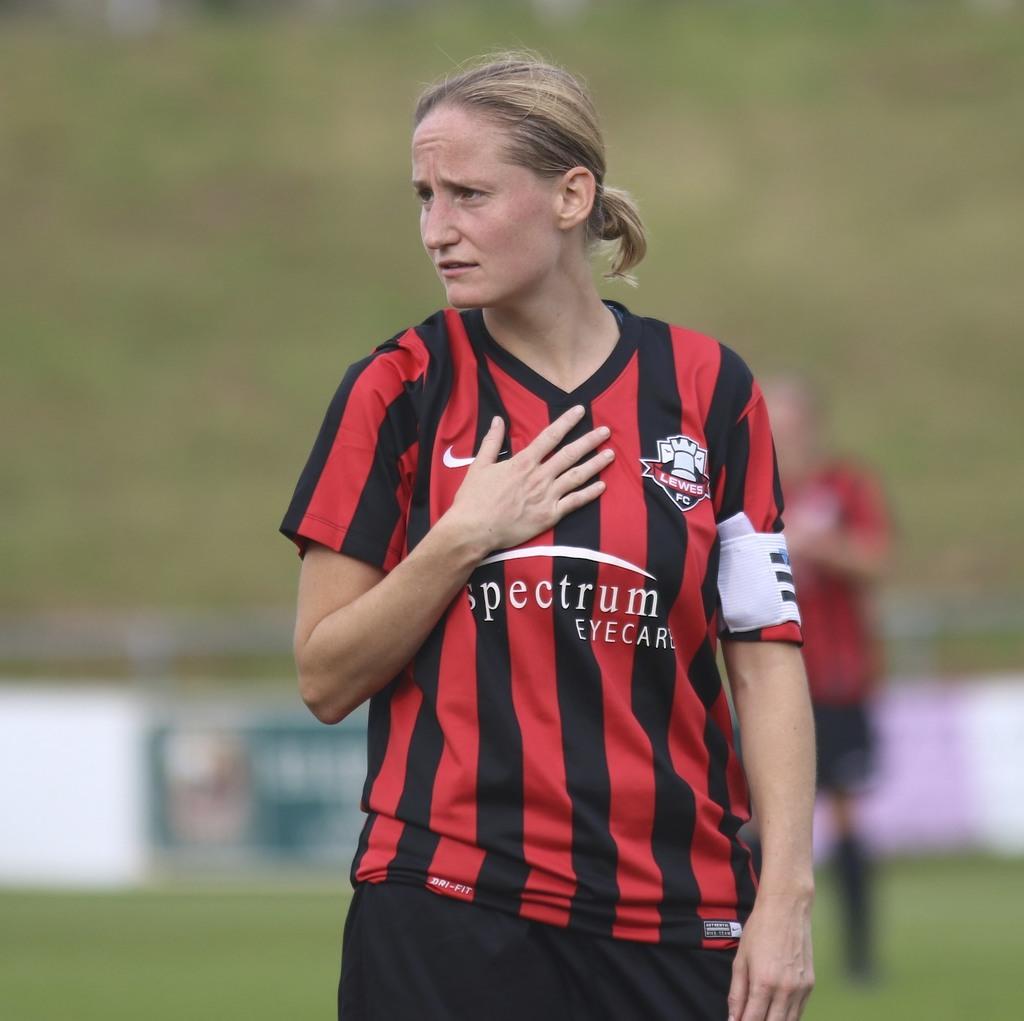What type of business is psectrum?
Offer a terse response. Eyecare. 